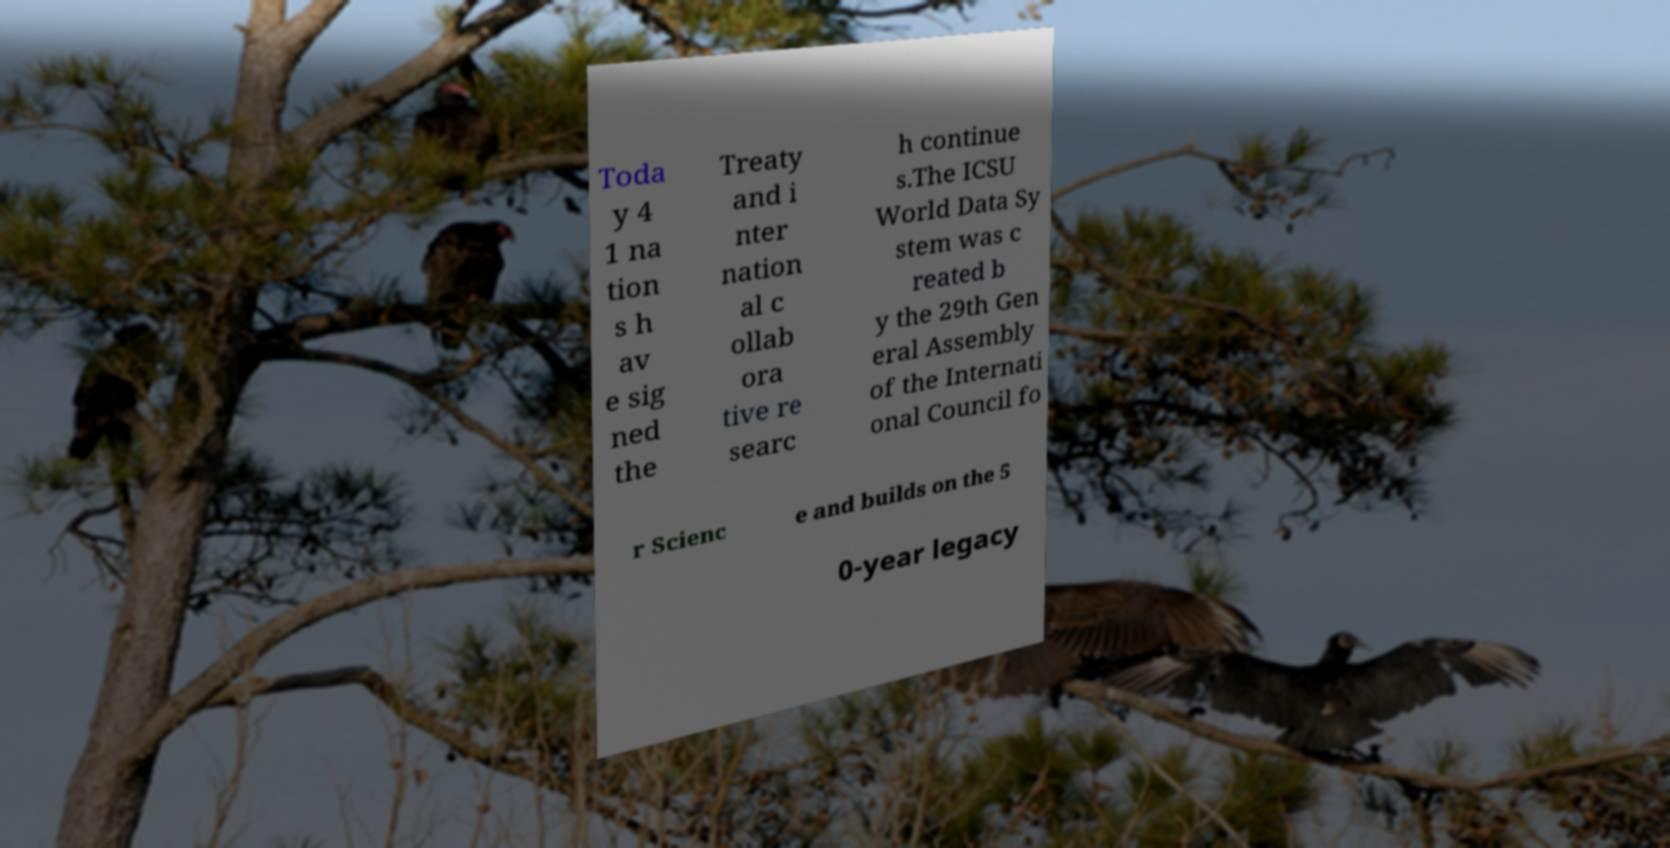What messages or text are displayed in this image? I need them in a readable, typed format. Toda y 4 1 na tion s h av e sig ned the Treaty and i nter nation al c ollab ora tive re searc h continue s.The ICSU World Data Sy stem was c reated b y the 29th Gen eral Assembly of the Internati onal Council fo r Scienc e and builds on the 5 0-year legacy 